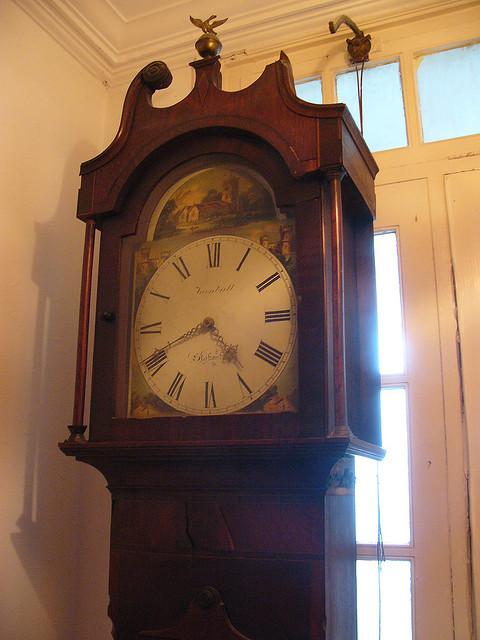Are the windows open?
Quick response, please. No. How long until noon?
Keep it brief. 7 hours. What country is the clock in?
Keep it brief. Usa. What is at the top center of the clock?
Quick response, please. Ornament. What time is on this clock?
Keep it brief. 4:40. 